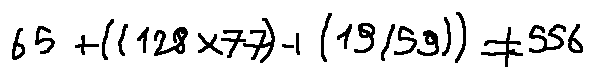Convert formula to latex. <formula><loc_0><loc_0><loc_500><loc_500>6 5 + ( ( 1 2 8 \times 7 7 ) + ( 1 9 / 5 9 ) ) \neq 5 5 6</formula> 